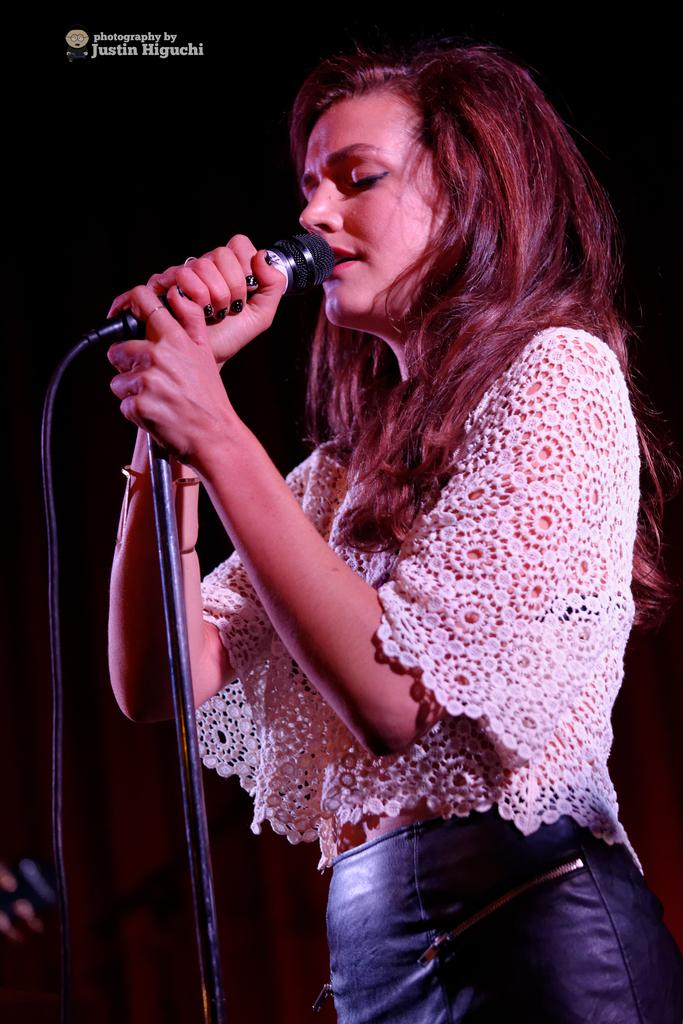Who is the main subject in the image? There is a woman in the image. What is the woman doing in the image? The woman is standing and singing in the image. What is the woman using to amplify her voice? She is in front of a microphone. What is the woman wearing on her upper body? The woman is wearing a white shirt. What is the woman wearing on her lower body? The woman is wearing blue jeans. What type of operation is the woman performing on the hydrant in the image? There is no hydrant present in the image, and the woman is not performing any operation. 